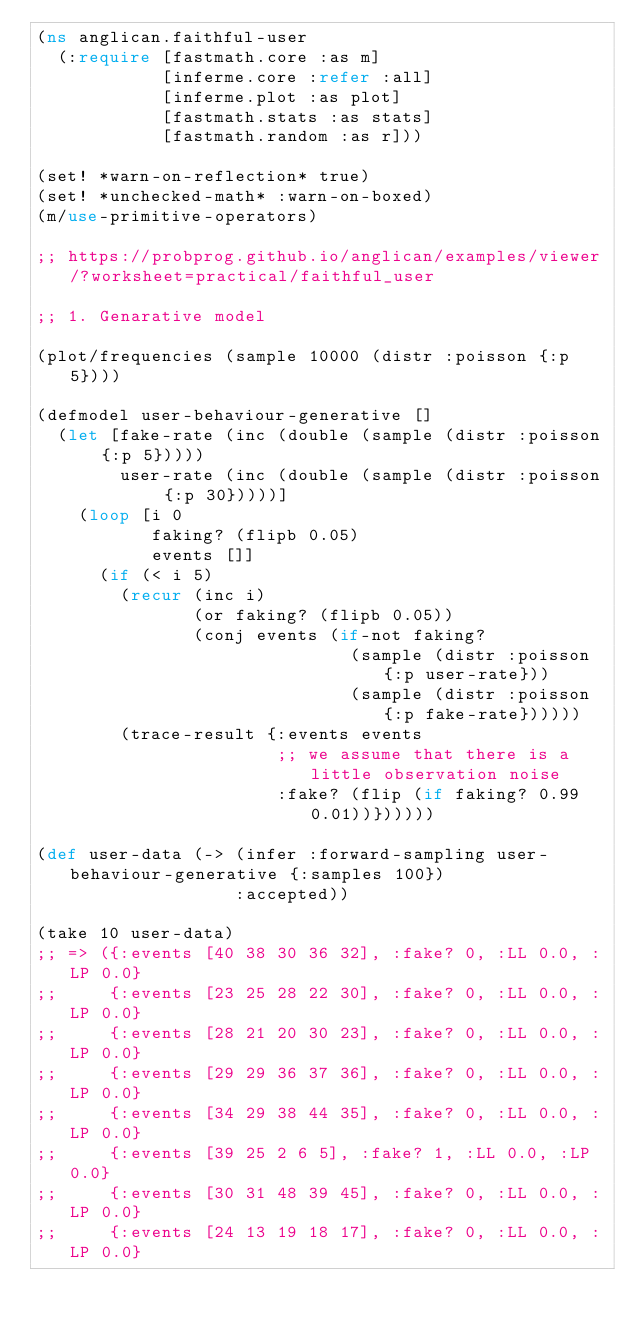<code> <loc_0><loc_0><loc_500><loc_500><_Clojure_>(ns anglican.faithful-user
  (:require [fastmath.core :as m]
            [inferme.core :refer :all]
            [inferme.plot :as plot]
            [fastmath.stats :as stats]
            [fastmath.random :as r]))

(set! *warn-on-reflection* true)
(set! *unchecked-math* :warn-on-boxed)
(m/use-primitive-operators)

;; https://probprog.github.io/anglican/examples/viewer/?worksheet=practical/faithful_user

;; 1. Genarative model

(plot/frequencies (sample 10000 (distr :poisson {:p 5})))

(defmodel user-behaviour-generative []
  (let [fake-rate (inc (double (sample (distr :poisson {:p 5}))))
        user-rate (inc (double (sample (distr :poisson {:p 30}))))]
    (loop [i 0
           faking? (flipb 0.05)
           events []]
      (if (< i 5)
        (recur (inc i) 
               (or faking? (flipb 0.05))
               (conj events (if-not faking?
                              (sample (distr :poisson {:p user-rate}))
                              (sample (distr :poisson {:p fake-rate})))))
        (trace-result {:events events
                       ;; we assume that there is a little observation noise
                       :fake? (flip (if faking? 0.99 0.01))})))))

(def user-data (-> (infer :forward-sampling user-behaviour-generative {:samples 100})
                   :accepted))

(take 10 user-data)
;; => ({:events [40 38 30 36 32], :fake? 0, :LL 0.0, :LP 0.0}
;;     {:events [23 25 28 22 30], :fake? 0, :LL 0.0, :LP 0.0}
;;     {:events [28 21 20 30 23], :fake? 0, :LL 0.0, :LP 0.0}
;;     {:events [29 29 36 37 36], :fake? 0, :LL 0.0, :LP 0.0}
;;     {:events [34 29 38 44 35], :fake? 0, :LL 0.0, :LP 0.0}
;;     {:events [39 25 2 6 5], :fake? 1, :LL 0.0, :LP 0.0}
;;     {:events [30 31 48 39 45], :fake? 0, :LL 0.0, :LP 0.0}
;;     {:events [24 13 19 18 17], :fake? 0, :LL 0.0, :LP 0.0}</code> 